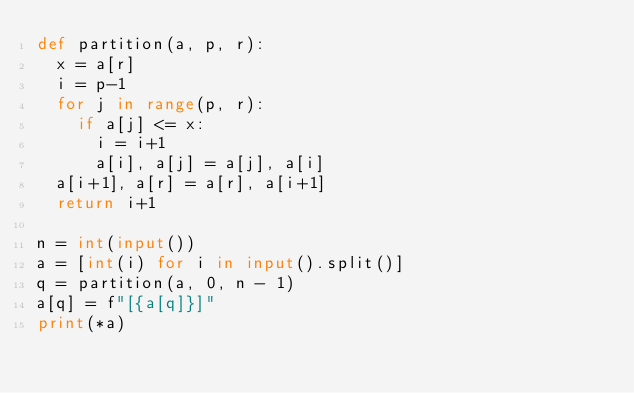Convert code to text. <code><loc_0><loc_0><loc_500><loc_500><_Python_>def partition(a, p, r):
  x = a[r]
  i = p-1
  for j in range(p, r):
    if a[j] <= x:
      i = i+1
      a[i], a[j] = a[j], a[i]
  a[i+1], a[r] = a[r], a[i+1]
  return i+1

n = int(input())
a = [int(i) for i in input().split()]
q = partition(a, 0, n - 1)
a[q] = f"[{a[q]}]"
print(*a)

</code> 